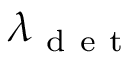Convert formula to latex. <formula><loc_0><loc_0><loc_500><loc_500>\lambda _ { d e t }</formula> 